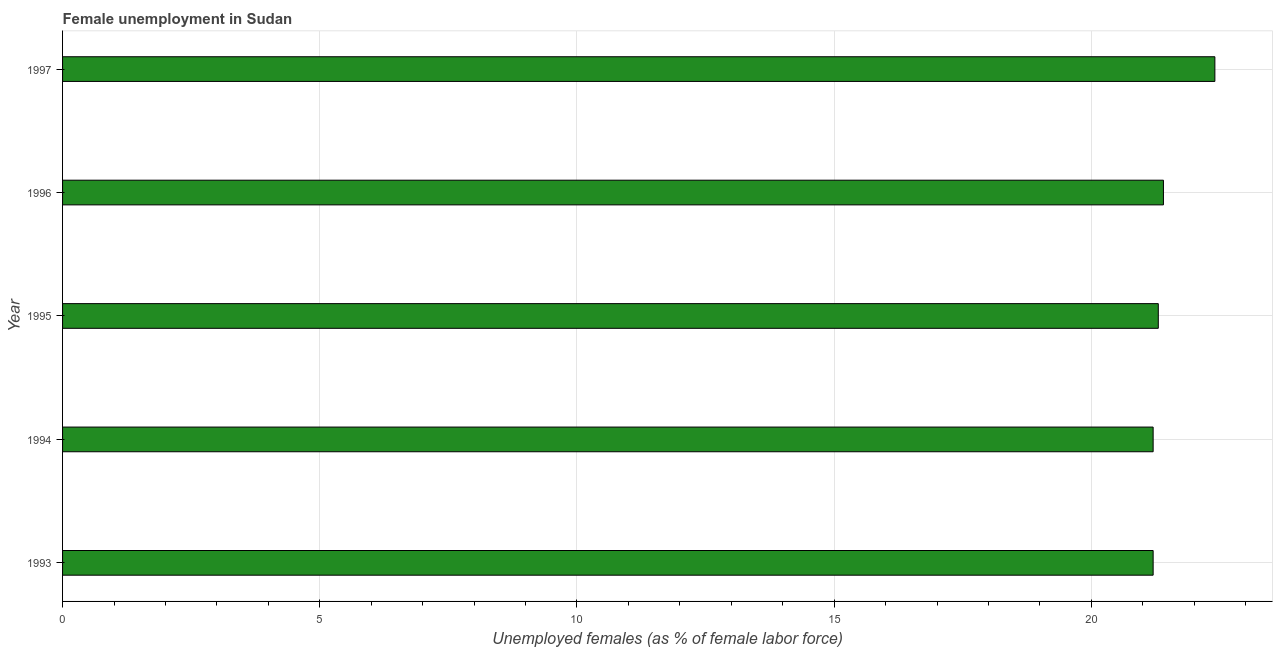Does the graph contain any zero values?
Make the answer very short. No. What is the title of the graph?
Provide a short and direct response. Female unemployment in Sudan. What is the label or title of the X-axis?
Ensure brevity in your answer.  Unemployed females (as % of female labor force). What is the unemployed females population in 1997?
Keep it short and to the point. 22.4. Across all years, what is the maximum unemployed females population?
Provide a succinct answer. 22.4. Across all years, what is the minimum unemployed females population?
Your answer should be compact. 21.2. In which year was the unemployed females population minimum?
Your answer should be very brief. 1993. What is the sum of the unemployed females population?
Ensure brevity in your answer.  107.5. What is the difference between the unemployed females population in 1993 and 1995?
Ensure brevity in your answer.  -0.1. What is the median unemployed females population?
Provide a short and direct response. 21.3. What is the ratio of the unemployed females population in 1993 to that in 1996?
Ensure brevity in your answer.  0.99. Is the difference between the unemployed females population in 1996 and 1997 greater than the difference between any two years?
Keep it short and to the point. No. Is the sum of the unemployed females population in 1993 and 1996 greater than the maximum unemployed females population across all years?
Your answer should be compact. Yes. What is the difference between the highest and the lowest unemployed females population?
Your answer should be very brief. 1.2. In how many years, is the unemployed females population greater than the average unemployed females population taken over all years?
Provide a short and direct response. 1. How many bars are there?
Make the answer very short. 5. Are all the bars in the graph horizontal?
Your response must be concise. Yes. What is the Unemployed females (as % of female labor force) in 1993?
Offer a terse response. 21.2. What is the Unemployed females (as % of female labor force) in 1994?
Make the answer very short. 21.2. What is the Unemployed females (as % of female labor force) in 1995?
Provide a short and direct response. 21.3. What is the Unemployed females (as % of female labor force) of 1996?
Your answer should be compact. 21.4. What is the Unemployed females (as % of female labor force) of 1997?
Offer a very short reply. 22.4. What is the difference between the Unemployed females (as % of female labor force) in 1993 and 1995?
Offer a very short reply. -0.1. What is the difference between the Unemployed females (as % of female labor force) in 1994 and 1995?
Provide a short and direct response. -0.1. What is the difference between the Unemployed females (as % of female labor force) in 1994 and 1997?
Keep it short and to the point. -1.2. What is the difference between the Unemployed females (as % of female labor force) in 1995 and 1996?
Offer a terse response. -0.1. What is the difference between the Unemployed females (as % of female labor force) in 1996 and 1997?
Make the answer very short. -1. What is the ratio of the Unemployed females (as % of female labor force) in 1993 to that in 1995?
Give a very brief answer. 0.99. What is the ratio of the Unemployed females (as % of female labor force) in 1993 to that in 1996?
Offer a very short reply. 0.99. What is the ratio of the Unemployed females (as % of female labor force) in 1993 to that in 1997?
Your response must be concise. 0.95. What is the ratio of the Unemployed females (as % of female labor force) in 1994 to that in 1997?
Your answer should be compact. 0.95. What is the ratio of the Unemployed females (as % of female labor force) in 1995 to that in 1997?
Your answer should be very brief. 0.95. What is the ratio of the Unemployed females (as % of female labor force) in 1996 to that in 1997?
Your answer should be very brief. 0.95. 